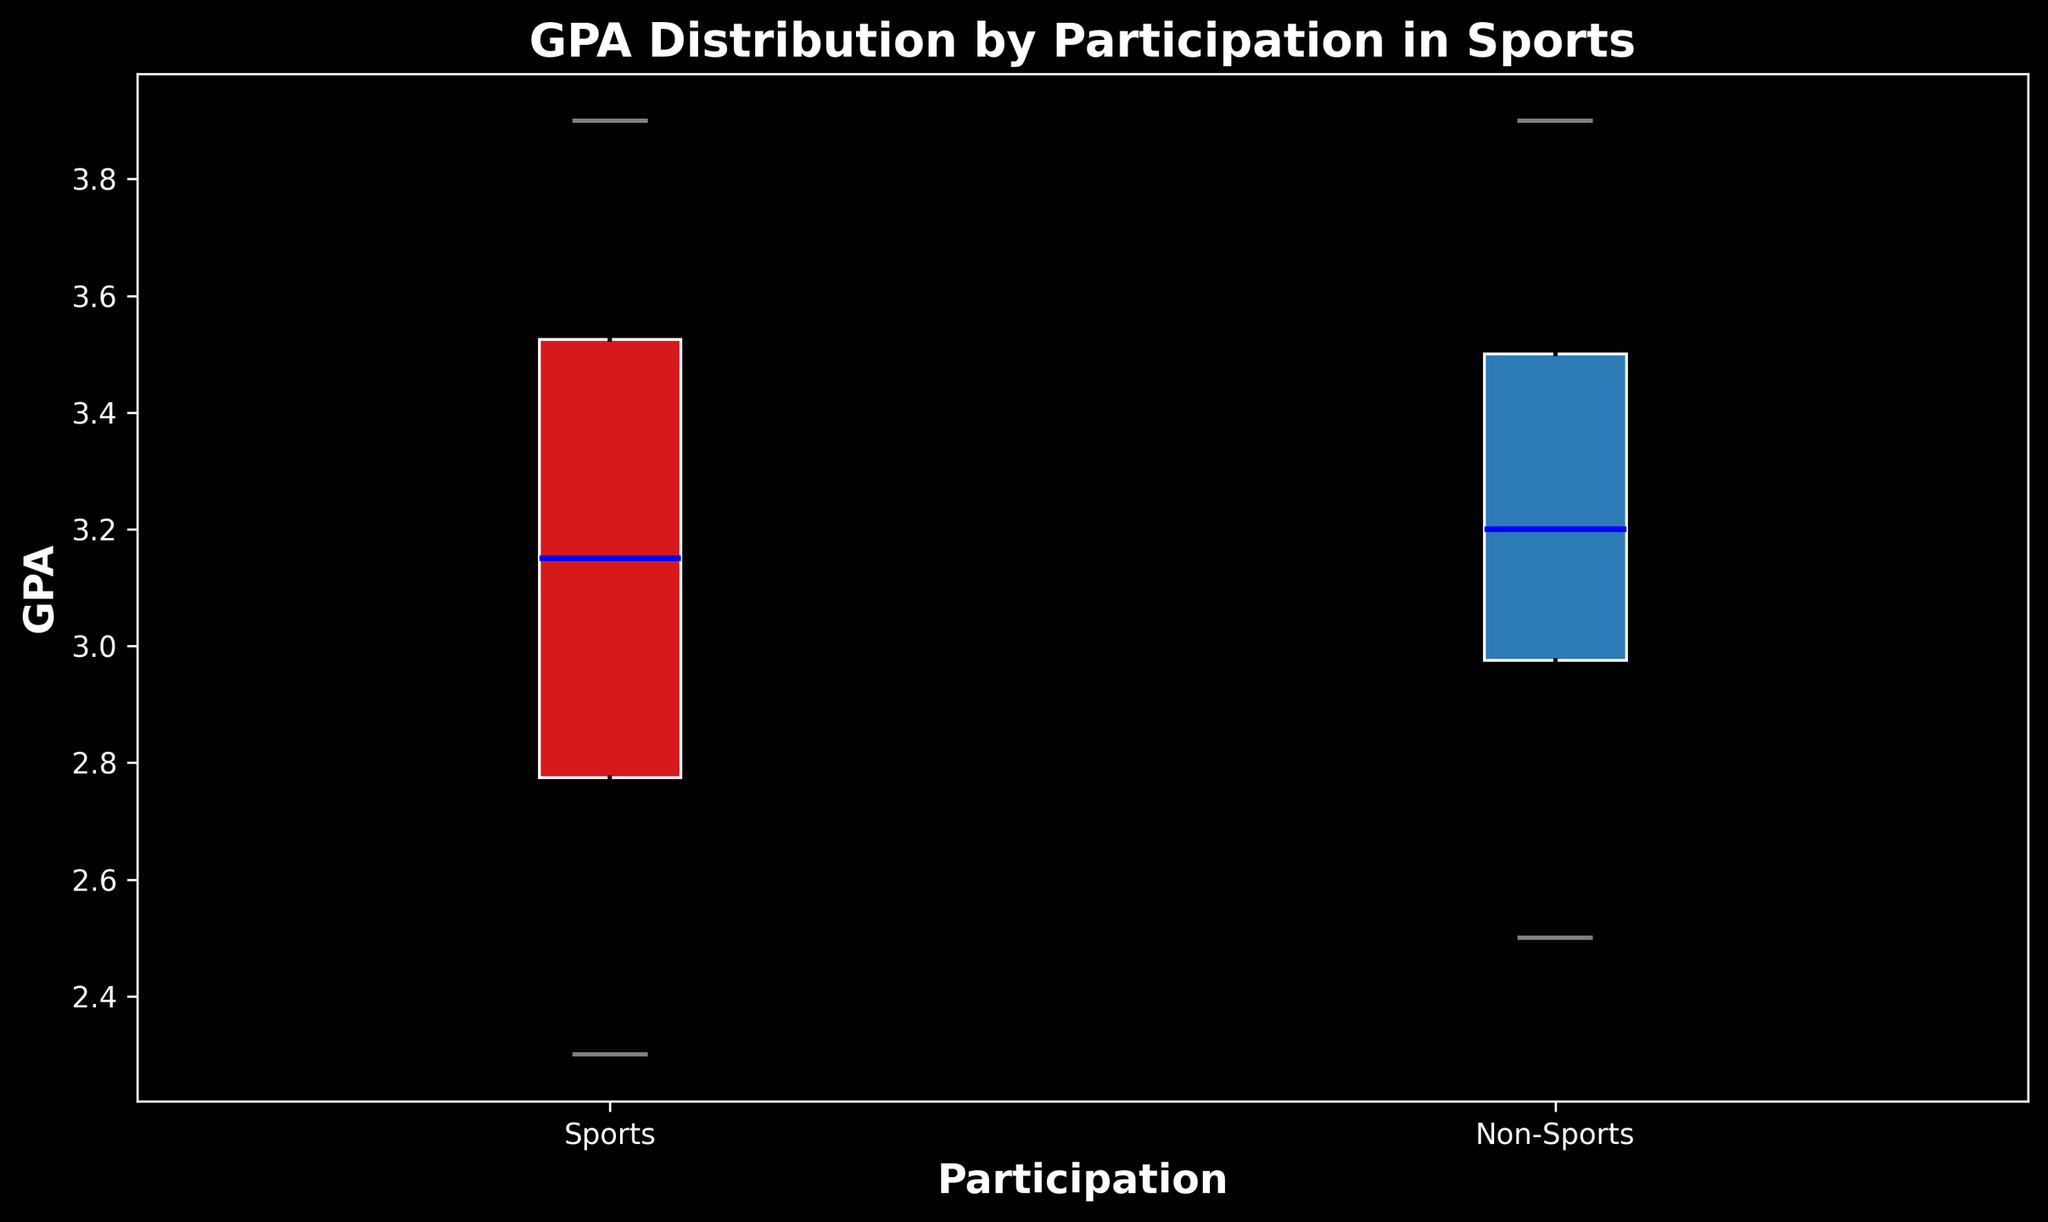How does the median GPA of students participating in sports compare to those not participating in sports? To determine this, look at the median lines inside each box in the box plot. The median is where the box is divided into two equal parts. Compare the heights of these lines for each category.
Answer: Sports median is approximately 3.3, Non-Sports median is approximately 3.3 Which group has a wider range of GPAs? The range of GPA is the distance between the lowest (minimum) and highest (maximum) points. Find the whiskers (lines extending from the box) for each group and compare the distances.
Answer: Sports has a wider range of GPAs What is the interquartile range (IQR) for the sports group, and how does it compare with the non-sports group? The IQR is the distance between the top of the lower quartile (bottom edge of the box) and the bottom of the upper quartile (top edge of the box). Identify these edges for both groups and compare the distances.
Answer: IQR for Sports ≈ 3.7 - 2.8 = 0.9, Non-Sports ≈ 3.7 - 3.0 = 0.7 Are there more outliers in the sports group or the non-sports group? Outliers are represented by individual points outside of the whiskers. Count the outliers for each group by identifying the points that are away from the box and whiskers.
Answer: Sports group Which group has the highest maximum GPA? Look at the top whisker for both groups to find the maximum GPA. Compare the ends of these whiskers to determine the higher maximum.
Answer: Non-Sports group Is the distribution of GPAs more varied in the sports or non-sports group? To determine the variation, observe the width of the box and the spread of the whiskers. A larger spread indicates more variation. Compare these features for both groups.
Answer: Sports group What colors are used to represent the sports and non-sports groups in the plot? Identify the colors of the boxes in the plot to determine which color represents each group.
Answer: Sports is red, Non-Sports is blue Does the sports group have any significantly low outliers, and if so, what is the approximate GPA of the lowest outlier? Identify any points that fall significantly below the lower whisker of the sports group. Note the position of the lowest outlier in terms of GPA.
Answer: Yes, approximately 2.3 Which group has a higher third quartile? The third quartile (Q3) is the top edge of the box. Compare the heights of the top edges of the boxes for each group to identify which has a higher Q3.
Answer: Both have the same, approximately 3.7 What is the approximate difference between the highest GPA in the sports group and the lowest GPA in the non-sports group? Determine the highest GPA in the sports group by locating the top of the upper whisker and the lowest GPA in the non-sports group by locating the bottom of the lower whisker. Calculate the difference between these two values.
Answer: Approximate difference is 3.9 - 2.5 = 1.4 